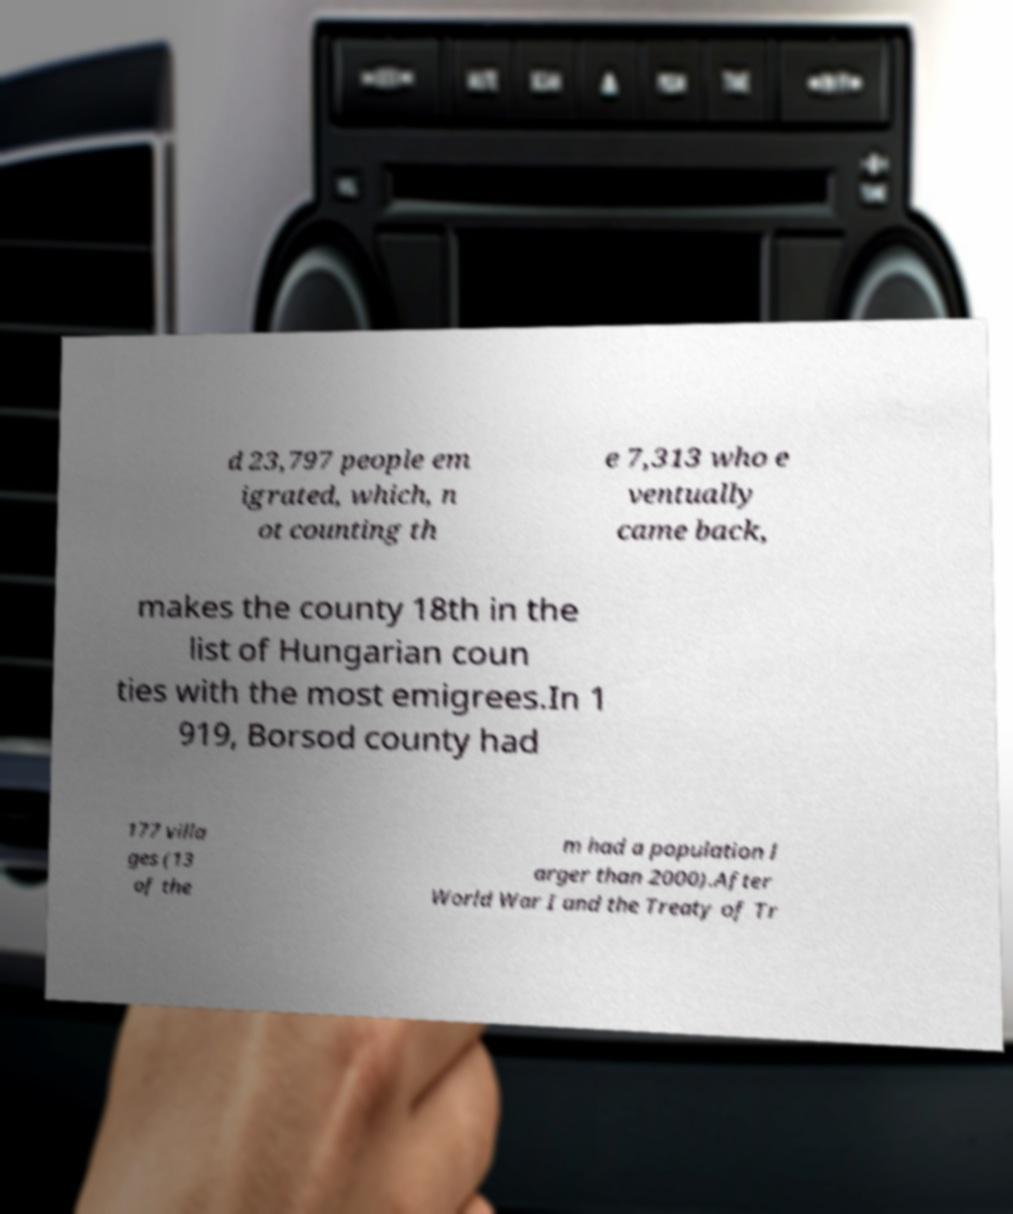Please read and relay the text visible in this image. What does it say? d 23,797 people em igrated, which, n ot counting th e 7,313 who e ventually came back, makes the county 18th in the list of Hungarian coun ties with the most emigrees.In 1 919, Borsod county had 177 villa ges (13 of the m had a population l arger than 2000).After World War I and the Treaty of Tr 